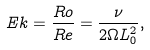Convert formula to latex. <formula><loc_0><loc_0><loc_500><loc_500>E k = \frac { R o } { R e } = \frac { \nu } { 2 \Omega L _ { 0 } ^ { 2 } } ,</formula> 